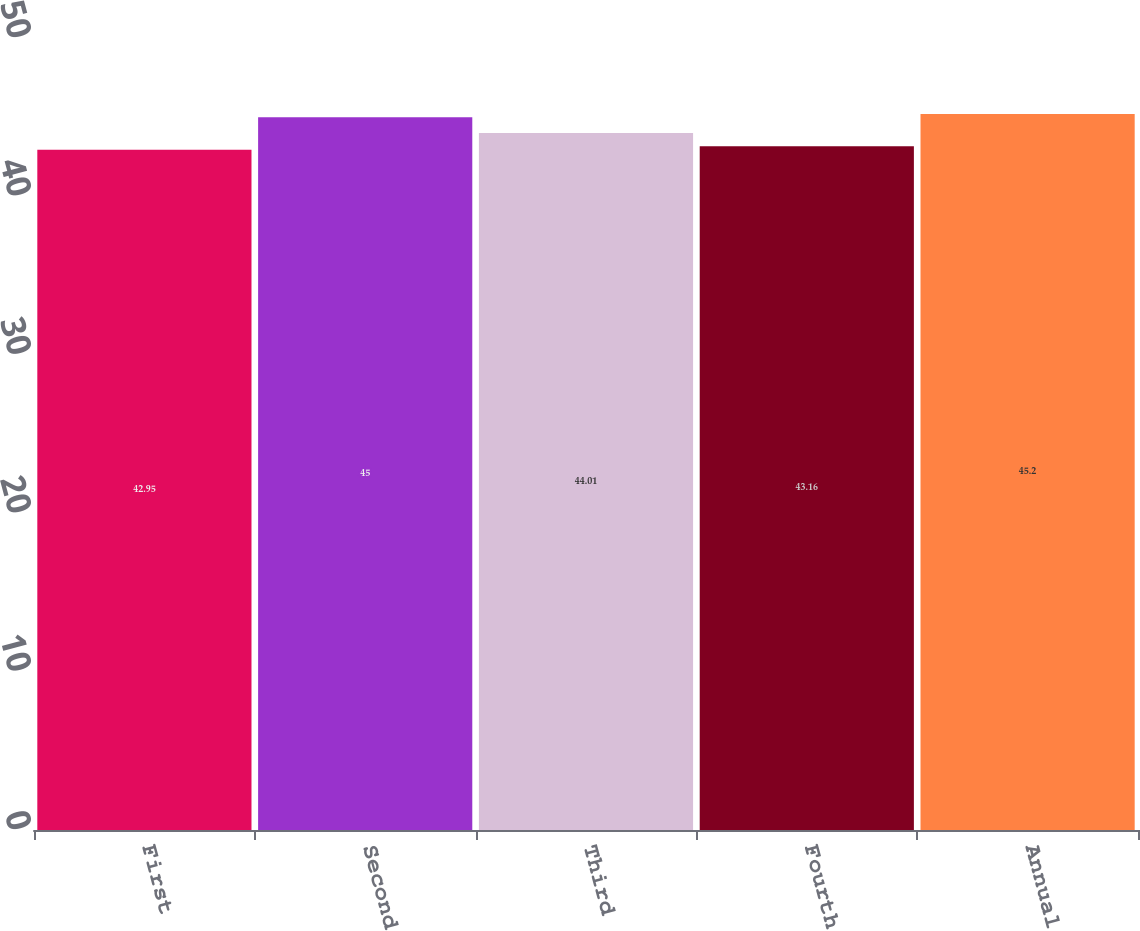Convert chart. <chart><loc_0><loc_0><loc_500><loc_500><bar_chart><fcel>First<fcel>Second<fcel>Third<fcel>Fourth<fcel>Annual<nl><fcel>42.95<fcel>45<fcel>44.01<fcel>43.16<fcel>45.2<nl></chart> 